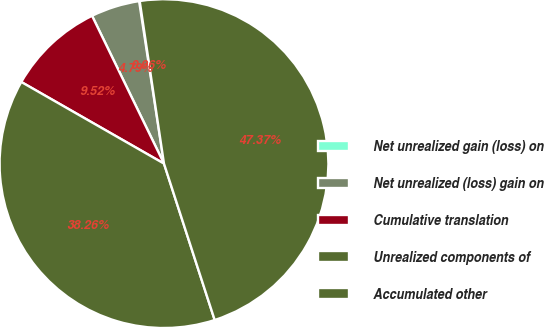Convert chart to OTSL. <chart><loc_0><loc_0><loc_500><loc_500><pie_chart><fcel>Net unrealized gain (loss) on<fcel>Net unrealized (loss) gain on<fcel>Cumulative translation<fcel>Unrealized components of<fcel>Accumulated other<nl><fcel>0.06%<fcel>4.79%<fcel>9.52%<fcel>38.26%<fcel>47.37%<nl></chart> 